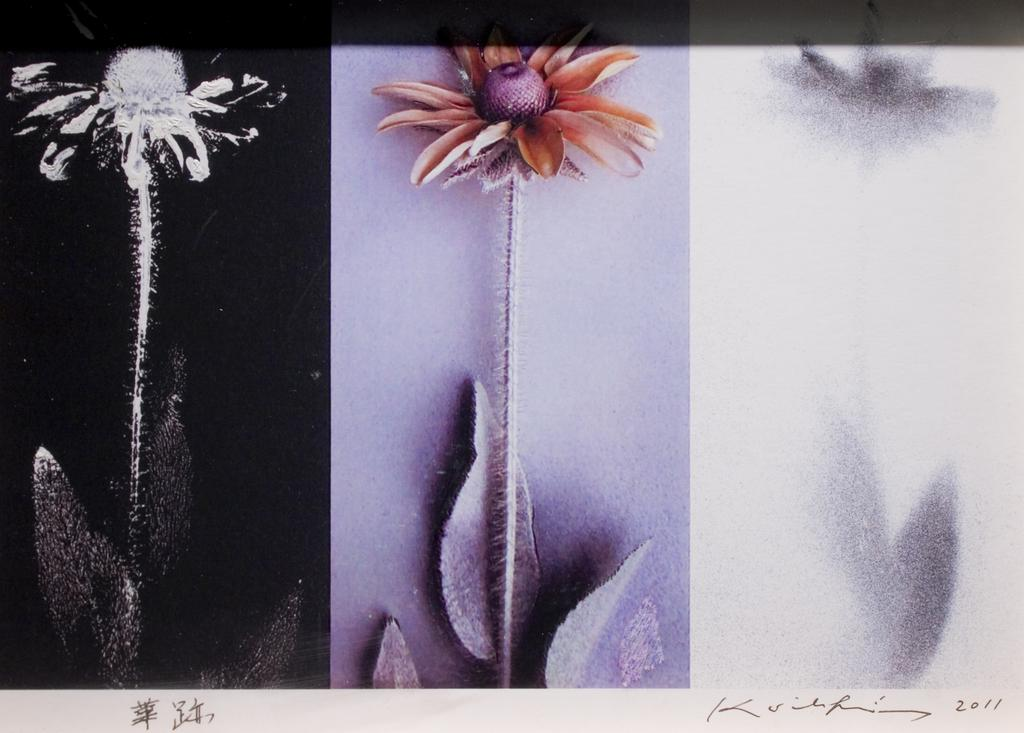What is the main subject of the image? The main subject of the image is a collage of flower pictures. How many images of the same flower are included in the collage? There are three images of the same flower in the collage. How are the three images of the same flower different from each other? The three images are edited in different ways. What type of silk fabric is used to create the background of the image? There is no silk fabric present in the image; it is a collage of flower pictures. How many bikes are visible in the image? There are no bikes present in the image; it is a collage of flower pictures. 